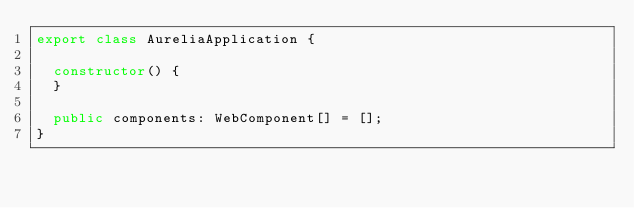<code> <loc_0><loc_0><loc_500><loc_500><_TypeScript_>export class AureliaApplication {

  constructor() {
  }

  public components: WebComponent[] = [];
}
</code> 